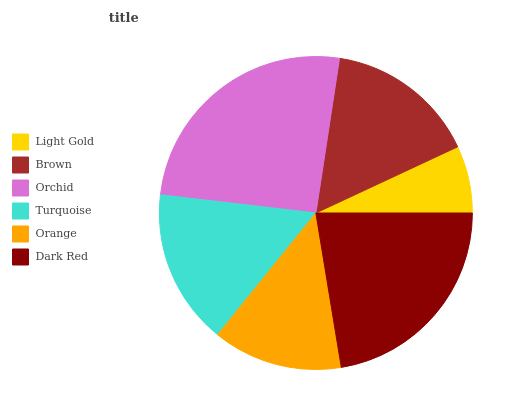Is Light Gold the minimum?
Answer yes or no. Yes. Is Orchid the maximum?
Answer yes or no. Yes. Is Brown the minimum?
Answer yes or no. No. Is Brown the maximum?
Answer yes or no. No. Is Brown greater than Light Gold?
Answer yes or no. Yes. Is Light Gold less than Brown?
Answer yes or no. Yes. Is Light Gold greater than Brown?
Answer yes or no. No. Is Brown less than Light Gold?
Answer yes or no. No. Is Turquoise the high median?
Answer yes or no. Yes. Is Brown the low median?
Answer yes or no. Yes. Is Orchid the high median?
Answer yes or no. No. Is Orchid the low median?
Answer yes or no. No. 